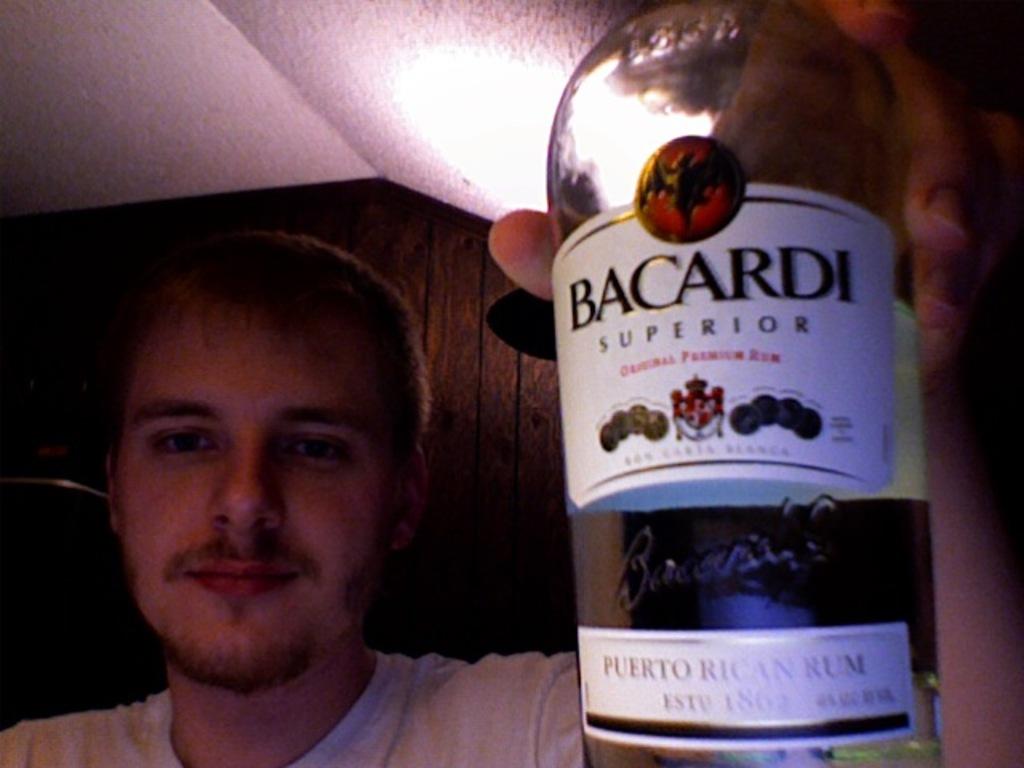What country is the rum from?
Ensure brevity in your answer.  Puerto rico. 